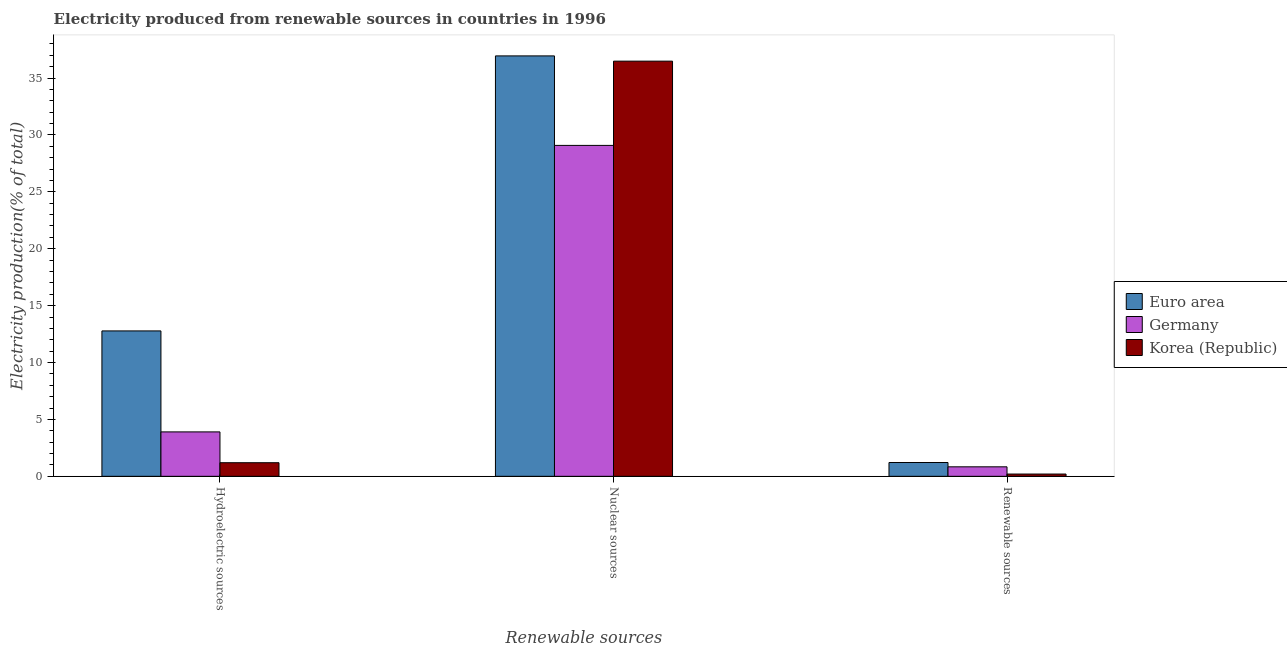How many different coloured bars are there?
Offer a terse response. 3. Are the number of bars per tick equal to the number of legend labels?
Keep it short and to the point. Yes. How many bars are there on the 3rd tick from the left?
Your answer should be very brief. 3. What is the label of the 2nd group of bars from the left?
Ensure brevity in your answer.  Nuclear sources. What is the percentage of electricity produced by hydroelectric sources in Euro area?
Provide a succinct answer. 12.78. Across all countries, what is the maximum percentage of electricity produced by nuclear sources?
Your answer should be compact. 36.95. Across all countries, what is the minimum percentage of electricity produced by hydroelectric sources?
Make the answer very short. 1.2. In which country was the percentage of electricity produced by hydroelectric sources minimum?
Provide a succinct answer. Korea (Republic). What is the total percentage of electricity produced by hydroelectric sources in the graph?
Offer a very short reply. 17.88. What is the difference between the percentage of electricity produced by nuclear sources in Euro area and that in Korea (Republic)?
Provide a short and direct response. 0.46. What is the difference between the percentage of electricity produced by nuclear sources in Korea (Republic) and the percentage of electricity produced by renewable sources in Euro area?
Offer a very short reply. 35.27. What is the average percentage of electricity produced by nuclear sources per country?
Give a very brief answer. 34.17. What is the difference between the percentage of electricity produced by renewable sources and percentage of electricity produced by nuclear sources in Korea (Republic)?
Your answer should be compact. -36.29. What is the ratio of the percentage of electricity produced by nuclear sources in Euro area to that in Germany?
Ensure brevity in your answer.  1.27. Is the percentage of electricity produced by renewable sources in Korea (Republic) less than that in Germany?
Provide a short and direct response. Yes. Is the difference between the percentage of electricity produced by hydroelectric sources in Germany and Korea (Republic) greater than the difference between the percentage of electricity produced by nuclear sources in Germany and Korea (Republic)?
Give a very brief answer. Yes. What is the difference between the highest and the second highest percentage of electricity produced by renewable sources?
Offer a very short reply. 0.38. What is the difference between the highest and the lowest percentage of electricity produced by hydroelectric sources?
Offer a very short reply. 11.58. In how many countries, is the percentage of electricity produced by hydroelectric sources greater than the average percentage of electricity produced by hydroelectric sources taken over all countries?
Make the answer very short. 1. What does the 3rd bar from the left in Hydroelectric sources represents?
Your answer should be compact. Korea (Republic). How many bars are there?
Offer a very short reply. 9. What is the difference between two consecutive major ticks on the Y-axis?
Provide a succinct answer. 5. Does the graph contain any zero values?
Your answer should be very brief. No. Where does the legend appear in the graph?
Offer a terse response. Center right. How are the legend labels stacked?
Ensure brevity in your answer.  Vertical. What is the title of the graph?
Give a very brief answer. Electricity produced from renewable sources in countries in 1996. Does "Barbados" appear as one of the legend labels in the graph?
Your answer should be very brief. No. What is the label or title of the X-axis?
Offer a very short reply. Renewable sources. What is the label or title of the Y-axis?
Offer a very short reply. Electricity production(% of total). What is the Electricity production(% of total) of Euro area in Hydroelectric sources?
Offer a very short reply. 12.78. What is the Electricity production(% of total) in Germany in Hydroelectric sources?
Provide a short and direct response. 3.9. What is the Electricity production(% of total) in Korea (Republic) in Hydroelectric sources?
Offer a terse response. 1.2. What is the Electricity production(% of total) in Euro area in Nuclear sources?
Make the answer very short. 36.95. What is the Electricity production(% of total) in Germany in Nuclear sources?
Your answer should be compact. 29.08. What is the Electricity production(% of total) of Korea (Republic) in Nuclear sources?
Make the answer very short. 36.49. What is the Electricity production(% of total) in Euro area in Renewable sources?
Your answer should be compact. 1.21. What is the Electricity production(% of total) in Germany in Renewable sources?
Keep it short and to the point. 0.83. What is the Electricity production(% of total) in Korea (Republic) in Renewable sources?
Provide a short and direct response. 0.2. Across all Renewable sources, what is the maximum Electricity production(% of total) of Euro area?
Ensure brevity in your answer.  36.95. Across all Renewable sources, what is the maximum Electricity production(% of total) of Germany?
Provide a succinct answer. 29.08. Across all Renewable sources, what is the maximum Electricity production(% of total) of Korea (Republic)?
Your response must be concise. 36.49. Across all Renewable sources, what is the minimum Electricity production(% of total) in Euro area?
Provide a short and direct response. 1.21. Across all Renewable sources, what is the minimum Electricity production(% of total) of Germany?
Your answer should be compact. 0.83. Across all Renewable sources, what is the minimum Electricity production(% of total) in Korea (Republic)?
Your response must be concise. 0.2. What is the total Electricity production(% of total) in Euro area in the graph?
Keep it short and to the point. 50.94. What is the total Electricity production(% of total) in Germany in the graph?
Provide a succinct answer. 33.82. What is the total Electricity production(% of total) in Korea (Republic) in the graph?
Your response must be concise. 37.88. What is the difference between the Electricity production(% of total) in Euro area in Hydroelectric sources and that in Nuclear sources?
Keep it short and to the point. -24.17. What is the difference between the Electricity production(% of total) of Germany in Hydroelectric sources and that in Nuclear sources?
Ensure brevity in your answer.  -25.18. What is the difference between the Electricity production(% of total) in Korea (Republic) in Hydroelectric sources and that in Nuclear sources?
Offer a very short reply. -35.29. What is the difference between the Electricity production(% of total) in Euro area in Hydroelectric sources and that in Renewable sources?
Make the answer very short. 11.56. What is the difference between the Electricity production(% of total) of Germany in Hydroelectric sources and that in Renewable sources?
Make the answer very short. 3.07. What is the difference between the Electricity production(% of total) of Euro area in Nuclear sources and that in Renewable sources?
Offer a very short reply. 35.73. What is the difference between the Electricity production(% of total) in Germany in Nuclear sources and that in Renewable sources?
Your answer should be compact. 28.25. What is the difference between the Electricity production(% of total) of Korea (Republic) in Nuclear sources and that in Renewable sources?
Keep it short and to the point. 36.29. What is the difference between the Electricity production(% of total) in Euro area in Hydroelectric sources and the Electricity production(% of total) in Germany in Nuclear sources?
Offer a very short reply. -16.3. What is the difference between the Electricity production(% of total) in Euro area in Hydroelectric sources and the Electricity production(% of total) in Korea (Republic) in Nuclear sources?
Your answer should be very brief. -23.71. What is the difference between the Electricity production(% of total) in Germany in Hydroelectric sources and the Electricity production(% of total) in Korea (Republic) in Nuclear sources?
Give a very brief answer. -32.58. What is the difference between the Electricity production(% of total) of Euro area in Hydroelectric sources and the Electricity production(% of total) of Germany in Renewable sources?
Offer a very short reply. 11.94. What is the difference between the Electricity production(% of total) of Euro area in Hydroelectric sources and the Electricity production(% of total) of Korea (Republic) in Renewable sources?
Ensure brevity in your answer.  12.58. What is the difference between the Electricity production(% of total) in Germany in Hydroelectric sources and the Electricity production(% of total) in Korea (Republic) in Renewable sources?
Your answer should be compact. 3.7. What is the difference between the Electricity production(% of total) of Euro area in Nuclear sources and the Electricity production(% of total) of Germany in Renewable sources?
Your response must be concise. 36.11. What is the difference between the Electricity production(% of total) in Euro area in Nuclear sources and the Electricity production(% of total) in Korea (Republic) in Renewable sources?
Provide a succinct answer. 36.75. What is the difference between the Electricity production(% of total) in Germany in Nuclear sources and the Electricity production(% of total) in Korea (Republic) in Renewable sources?
Make the answer very short. 28.88. What is the average Electricity production(% of total) of Euro area per Renewable sources?
Your answer should be compact. 16.98. What is the average Electricity production(% of total) in Germany per Renewable sources?
Offer a very short reply. 11.27. What is the average Electricity production(% of total) in Korea (Republic) per Renewable sources?
Your response must be concise. 12.63. What is the difference between the Electricity production(% of total) of Euro area and Electricity production(% of total) of Germany in Hydroelectric sources?
Provide a succinct answer. 8.87. What is the difference between the Electricity production(% of total) in Euro area and Electricity production(% of total) in Korea (Republic) in Hydroelectric sources?
Offer a very short reply. 11.58. What is the difference between the Electricity production(% of total) in Germany and Electricity production(% of total) in Korea (Republic) in Hydroelectric sources?
Your answer should be compact. 2.71. What is the difference between the Electricity production(% of total) in Euro area and Electricity production(% of total) in Germany in Nuclear sources?
Keep it short and to the point. 7.87. What is the difference between the Electricity production(% of total) of Euro area and Electricity production(% of total) of Korea (Republic) in Nuclear sources?
Your answer should be very brief. 0.46. What is the difference between the Electricity production(% of total) in Germany and Electricity production(% of total) in Korea (Republic) in Nuclear sources?
Your answer should be compact. -7.4. What is the difference between the Electricity production(% of total) in Euro area and Electricity production(% of total) in Germany in Renewable sources?
Provide a short and direct response. 0.38. What is the difference between the Electricity production(% of total) of Germany and Electricity production(% of total) of Korea (Republic) in Renewable sources?
Make the answer very short. 0.63. What is the ratio of the Electricity production(% of total) of Euro area in Hydroelectric sources to that in Nuclear sources?
Your response must be concise. 0.35. What is the ratio of the Electricity production(% of total) of Germany in Hydroelectric sources to that in Nuclear sources?
Make the answer very short. 0.13. What is the ratio of the Electricity production(% of total) of Korea (Republic) in Hydroelectric sources to that in Nuclear sources?
Give a very brief answer. 0.03. What is the ratio of the Electricity production(% of total) of Euro area in Hydroelectric sources to that in Renewable sources?
Make the answer very short. 10.53. What is the ratio of the Electricity production(% of total) in Germany in Hydroelectric sources to that in Renewable sources?
Keep it short and to the point. 4.68. What is the ratio of the Electricity production(% of total) of Korea (Republic) in Hydroelectric sources to that in Renewable sources?
Provide a succinct answer. 5.97. What is the ratio of the Electricity production(% of total) of Euro area in Nuclear sources to that in Renewable sources?
Make the answer very short. 30.45. What is the ratio of the Electricity production(% of total) of Germany in Nuclear sources to that in Renewable sources?
Give a very brief answer. 34.83. What is the ratio of the Electricity production(% of total) of Korea (Republic) in Nuclear sources to that in Renewable sources?
Provide a succinct answer. 182.08. What is the difference between the highest and the second highest Electricity production(% of total) in Euro area?
Make the answer very short. 24.17. What is the difference between the highest and the second highest Electricity production(% of total) of Germany?
Ensure brevity in your answer.  25.18. What is the difference between the highest and the second highest Electricity production(% of total) in Korea (Republic)?
Offer a very short reply. 35.29. What is the difference between the highest and the lowest Electricity production(% of total) in Euro area?
Your answer should be very brief. 35.73. What is the difference between the highest and the lowest Electricity production(% of total) in Germany?
Your response must be concise. 28.25. What is the difference between the highest and the lowest Electricity production(% of total) in Korea (Republic)?
Offer a very short reply. 36.29. 